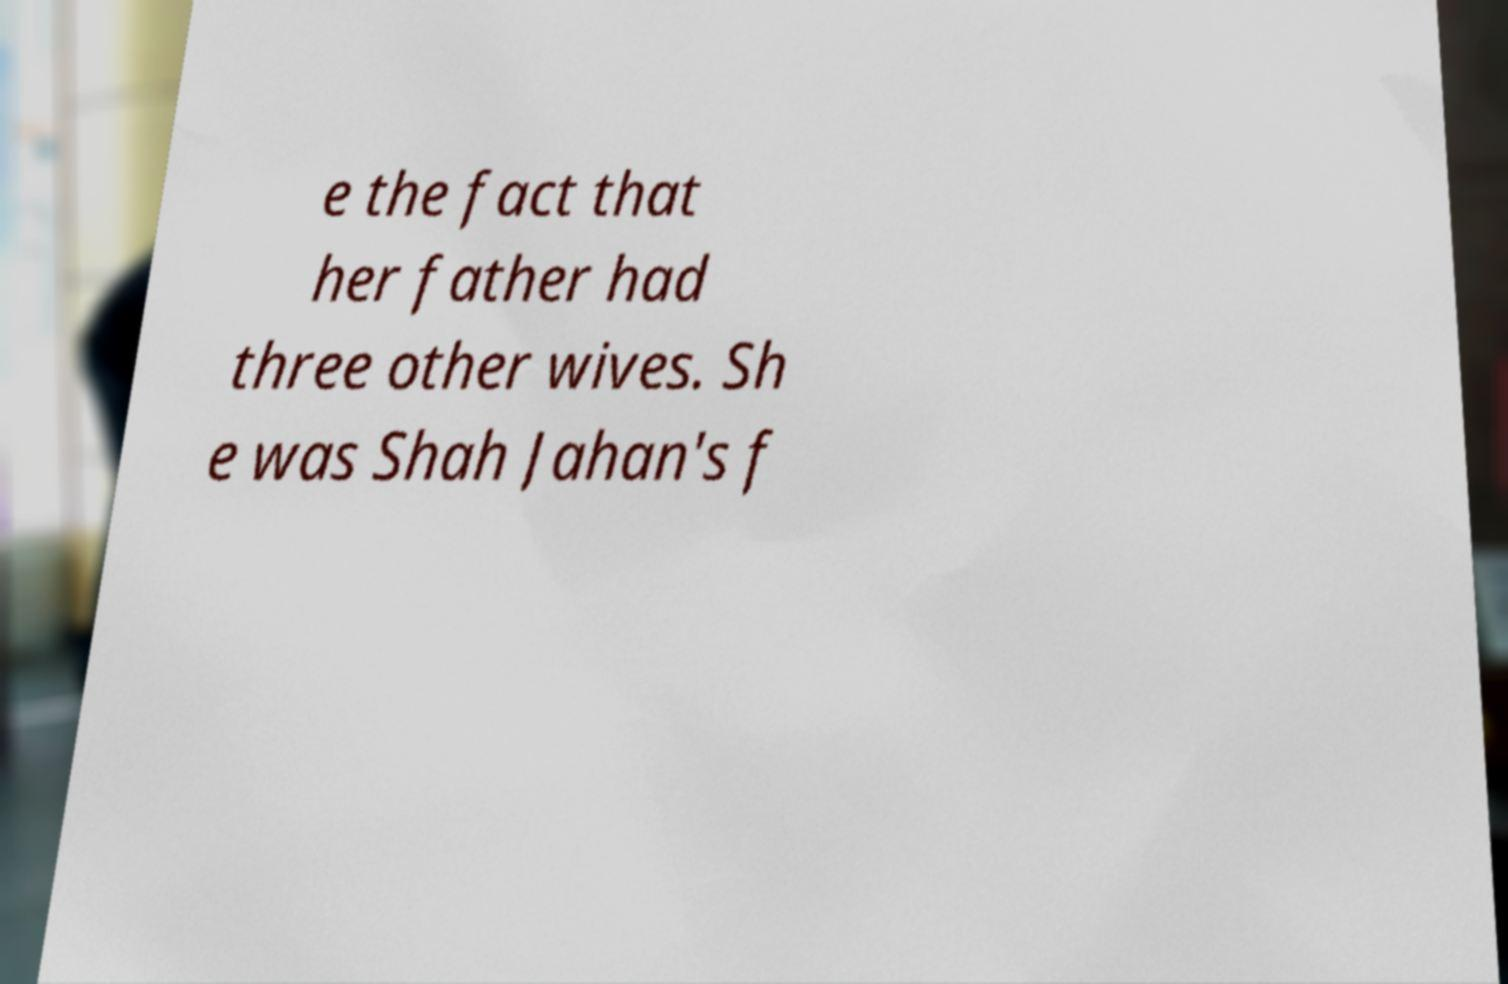For documentation purposes, I need the text within this image transcribed. Could you provide that? e the fact that her father had three other wives. Sh e was Shah Jahan's f 